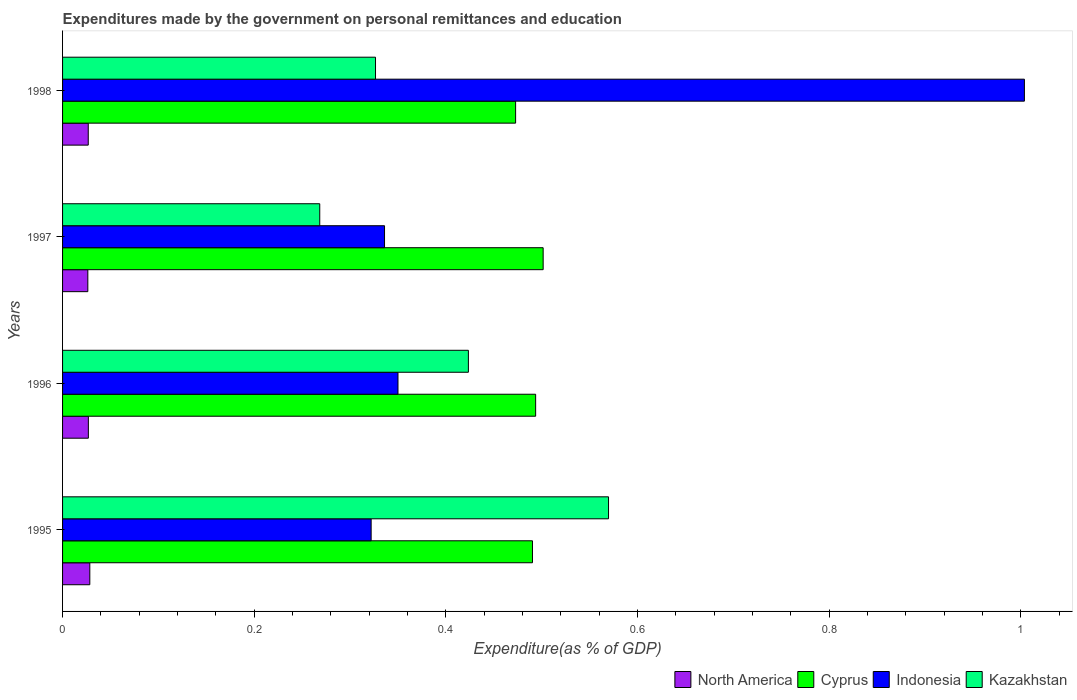How many different coloured bars are there?
Provide a succinct answer. 4. Are the number of bars per tick equal to the number of legend labels?
Your answer should be compact. Yes. Are the number of bars on each tick of the Y-axis equal?
Your response must be concise. Yes. What is the label of the 1st group of bars from the top?
Your response must be concise. 1998. What is the expenditures made by the government on personal remittances and education in Kazakhstan in 1998?
Ensure brevity in your answer.  0.33. Across all years, what is the maximum expenditures made by the government on personal remittances and education in Kazakhstan?
Your answer should be very brief. 0.57. Across all years, what is the minimum expenditures made by the government on personal remittances and education in Indonesia?
Your response must be concise. 0.32. What is the total expenditures made by the government on personal remittances and education in Cyprus in the graph?
Keep it short and to the point. 1.96. What is the difference between the expenditures made by the government on personal remittances and education in Cyprus in 1995 and that in 1996?
Offer a very short reply. -0. What is the difference between the expenditures made by the government on personal remittances and education in Kazakhstan in 1997 and the expenditures made by the government on personal remittances and education in Indonesia in 1998?
Your answer should be compact. -0.74. What is the average expenditures made by the government on personal remittances and education in Kazakhstan per year?
Ensure brevity in your answer.  0.4. In the year 1997, what is the difference between the expenditures made by the government on personal remittances and education in Indonesia and expenditures made by the government on personal remittances and education in Kazakhstan?
Offer a very short reply. 0.07. What is the ratio of the expenditures made by the government on personal remittances and education in Indonesia in 1996 to that in 1998?
Your answer should be compact. 0.35. Is the expenditures made by the government on personal remittances and education in Kazakhstan in 1995 less than that in 1996?
Your answer should be very brief. No. Is the difference between the expenditures made by the government on personal remittances and education in Indonesia in 1995 and 1997 greater than the difference between the expenditures made by the government on personal remittances and education in Kazakhstan in 1995 and 1997?
Offer a very short reply. No. What is the difference between the highest and the second highest expenditures made by the government on personal remittances and education in Kazakhstan?
Your response must be concise. 0.15. What is the difference between the highest and the lowest expenditures made by the government on personal remittances and education in North America?
Provide a short and direct response. 0. In how many years, is the expenditures made by the government on personal remittances and education in Cyprus greater than the average expenditures made by the government on personal remittances and education in Cyprus taken over all years?
Ensure brevity in your answer.  3. Is it the case that in every year, the sum of the expenditures made by the government on personal remittances and education in Kazakhstan and expenditures made by the government on personal remittances and education in North America is greater than the sum of expenditures made by the government on personal remittances and education in Indonesia and expenditures made by the government on personal remittances and education in Cyprus?
Ensure brevity in your answer.  No. What does the 2nd bar from the bottom in 1997 represents?
Your response must be concise. Cyprus. Is it the case that in every year, the sum of the expenditures made by the government on personal remittances and education in Indonesia and expenditures made by the government on personal remittances and education in Cyprus is greater than the expenditures made by the government on personal remittances and education in Kazakhstan?
Your response must be concise. Yes. How many years are there in the graph?
Give a very brief answer. 4. Are the values on the major ticks of X-axis written in scientific E-notation?
Keep it short and to the point. No. Does the graph contain grids?
Make the answer very short. No. Where does the legend appear in the graph?
Your answer should be very brief. Bottom right. What is the title of the graph?
Provide a succinct answer. Expenditures made by the government on personal remittances and education. What is the label or title of the X-axis?
Make the answer very short. Expenditure(as % of GDP). What is the label or title of the Y-axis?
Give a very brief answer. Years. What is the Expenditure(as % of GDP) of North America in 1995?
Ensure brevity in your answer.  0.03. What is the Expenditure(as % of GDP) in Cyprus in 1995?
Keep it short and to the point. 0.49. What is the Expenditure(as % of GDP) in Indonesia in 1995?
Your answer should be very brief. 0.32. What is the Expenditure(as % of GDP) of Kazakhstan in 1995?
Keep it short and to the point. 0.57. What is the Expenditure(as % of GDP) of North America in 1996?
Provide a short and direct response. 0.03. What is the Expenditure(as % of GDP) of Cyprus in 1996?
Provide a short and direct response. 0.49. What is the Expenditure(as % of GDP) of Indonesia in 1996?
Your answer should be very brief. 0.35. What is the Expenditure(as % of GDP) in Kazakhstan in 1996?
Offer a very short reply. 0.42. What is the Expenditure(as % of GDP) of North America in 1997?
Offer a terse response. 0.03. What is the Expenditure(as % of GDP) in Cyprus in 1997?
Offer a terse response. 0.5. What is the Expenditure(as % of GDP) of Indonesia in 1997?
Provide a short and direct response. 0.34. What is the Expenditure(as % of GDP) in Kazakhstan in 1997?
Make the answer very short. 0.27. What is the Expenditure(as % of GDP) in North America in 1998?
Keep it short and to the point. 0.03. What is the Expenditure(as % of GDP) in Cyprus in 1998?
Your answer should be very brief. 0.47. What is the Expenditure(as % of GDP) in Indonesia in 1998?
Offer a very short reply. 1. What is the Expenditure(as % of GDP) of Kazakhstan in 1998?
Your answer should be very brief. 0.33. Across all years, what is the maximum Expenditure(as % of GDP) in North America?
Offer a very short reply. 0.03. Across all years, what is the maximum Expenditure(as % of GDP) in Cyprus?
Offer a very short reply. 0.5. Across all years, what is the maximum Expenditure(as % of GDP) in Indonesia?
Your response must be concise. 1. Across all years, what is the maximum Expenditure(as % of GDP) in Kazakhstan?
Provide a succinct answer. 0.57. Across all years, what is the minimum Expenditure(as % of GDP) in North America?
Your answer should be compact. 0.03. Across all years, what is the minimum Expenditure(as % of GDP) in Cyprus?
Ensure brevity in your answer.  0.47. Across all years, what is the minimum Expenditure(as % of GDP) in Indonesia?
Offer a very short reply. 0.32. Across all years, what is the minimum Expenditure(as % of GDP) in Kazakhstan?
Your response must be concise. 0.27. What is the total Expenditure(as % of GDP) of North America in the graph?
Your answer should be compact. 0.11. What is the total Expenditure(as % of GDP) in Cyprus in the graph?
Offer a terse response. 1.96. What is the total Expenditure(as % of GDP) of Indonesia in the graph?
Give a very brief answer. 2.01. What is the total Expenditure(as % of GDP) in Kazakhstan in the graph?
Your answer should be very brief. 1.59. What is the difference between the Expenditure(as % of GDP) of North America in 1995 and that in 1996?
Offer a terse response. 0. What is the difference between the Expenditure(as % of GDP) in Cyprus in 1995 and that in 1996?
Your response must be concise. -0. What is the difference between the Expenditure(as % of GDP) of Indonesia in 1995 and that in 1996?
Provide a succinct answer. -0.03. What is the difference between the Expenditure(as % of GDP) in Kazakhstan in 1995 and that in 1996?
Offer a very short reply. 0.15. What is the difference between the Expenditure(as % of GDP) of North America in 1995 and that in 1997?
Offer a very short reply. 0. What is the difference between the Expenditure(as % of GDP) in Cyprus in 1995 and that in 1997?
Keep it short and to the point. -0.01. What is the difference between the Expenditure(as % of GDP) of Indonesia in 1995 and that in 1997?
Ensure brevity in your answer.  -0.01. What is the difference between the Expenditure(as % of GDP) of Kazakhstan in 1995 and that in 1997?
Your answer should be very brief. 0.3. What is the difference between the Expenditure(as % of GDP) of North America in 1995 and that in 1998?
Your answer should be very brief. 0. What is the difference between the Expenditure(as % of GDP) of Cyprus in 1995 and that in 1998?
Provide a succinct answer. 0.02. What is the difference between the Expenditure(as % of GDP) in Indonesia in 1995 and that in 1998?
Keep it short and to the point. -0.68. What is the difference between the Expenditure(as % of GDP) in Kazakhstan in 1995 and that in 1998?
Offer a very short reply. 0.24. What is the difference between the Expenditure(as % of GDP) in North America in 1996 and that in 1997?
Keep it short and to the point. 0. What is the difference between the Expenditure(as % of GDP) in Cyprus in 1996 and that in 1997?
Your answer should be compact. -0.01. What is the difference between the Expenditure(as % of GDP) of Indonesia in 1996 and that in 1997?
Offer a very short reply. 0.01. What is the difference between the Expenditure(as % of GDP) in Kazakhstan in 1996 and that in 1997?
Offer a very short reply. 0.16. What is the difference between the Expenditure(as % of GDP) of Cyprus in 1996 and that in 1998?
Your answer should be compact. 0.02. What is the difference between the Expenditure(as % of GDP) of Indonesia in 1996 and that in 1998?
Provide a short and direct response. -0.65. What is the difference between the Expenditure(as % of GDP) in Kazakhstan in 1996 and that in 1998?
Keep it short and to the point. 0.1. What is the difference between the Expenditure(as % of GDP) of North America in 1997 and that in 1998?
Offer a very short reply. -0. What is the difference between the Expenditure(as % of GDP) of Cyprus in 1997 and that in 1998?
Provide a short and direct response. 0.03. What is the difference between the Expenditure(as % of GDP) of Indonesia in 1997 and that in 1998?
Your answer should be very brief. -0.67. What is the difference between the Expenditure(as % of GDP) of Kazakhstan in 1997 and that in 1998?
Give a very brief answer. -0.06. What is the difference between the Expenditure(as % of GDP) of North America in 1995 and the Expenditure(as % of GDP) of Cyprus in 1996?
Keep it short and to the point. -0.47. What is the difference between the Expenditure(as % of GDP) of North America in 1995 and the Expenditure(as % of GDP) of Indonesia in 1996?
Your response must be concise. -0.32. What is the difference between the Expenditure(as % of GDP) in North America in 1995 and the Expenditure(as % of GDP) in Kazakhstan in 1996?
Provide a short and direct response. -0.4. What is the difference between the Expenditure(as % of GDP) in Cyprus in 1995 and the Expenditure(as % of GDP) in Indonesia in 1996?
Offer a very short reply. 0.14. What is the difference between the Expenditure(as % of GDP) of Cyprus in 1995 and the Expenditure(as % of GDP) of Kazakhstan in 1996?
Make the answer very short. 0.07. What is the difference between the Expenditure(as % of GDP) in Indonesia in 1995 and the Expenditure(as % of GDP) in Kazakhstan in 1996?
Keep it short and to the point. -0.1. What is the difference between the Expenditure(as % of GDP) in North America in 1995 and the Expenditure(as % of GDP) in Cyprus in 1997?
Make the answer very short. -0.47. What is the difference between the Expenditure(as % of GDP) in North America in 1995 and the Expenditure(as % of GDP) in Indonesia in 1997?
Your answer should be very brief. -0.31. What is the difference between the Expenditure(as % of GDP) in North America in 1995 and the Expenditure(as % of GDP) in Kazakhstan in 1997?
Give a very brief answer. -0.24. What is the difference between the Expenditure(as % of GDP) in Cyprus in 1995 and the Expenditure(as % of GDP) in Indonesia in 1997?
Your answer should be very brief. 0.15. What is the difference between the Expenditure(as % of GDP) in Cyprus in 1995 and the Expenditure(as % of GDP) in Kazakhstan in 1997?
Make the answer very short. 0.22. What is the difference between the Expenditure(as % of GDP) in Indonesia in 1995 and the Expenditure(as % of GDP) in Kazakhstan in 1997?
Give a very brief answer. 0.05. What is the difference between the Expenditure(as % of GDP) in North America in 1995 and the Expenditure(as % of GDP) in Cyprus in 1998?
Offer a terse response. -0.44. What is the difference between the Expenditure(as % of GDP) in North America in 1995 and the Expenditure(as % of GDP) in Indonesia in 1998?
Give a very brief answer. -0.98. What is the difference between the Expenditure(as % of GDP) of North America in 1995 and the Expenditure(as % of GDP) of Kazakhstan in 1998?
Give a very brief answer. -0.3. What is the difference between the Expenditure(as % of GDP) of Cyprus in 1995 and the Expenditure(as % of GDP) of Indonesia in 1998?
Give a very brief answer. -0.51. What is the difference between the Expenditure(as % of GDP) of Cyprus in 1995 and the Expenditure(as % of GDP) of Kazakhstan in 1998?
Provide a succinct answer. 0.16. What is the difference between the Expenditure(as % of GDP) of Indonesia in 1995 and the Expenditure(as % of GDP) of Kazakhstan in 1998?
Give a very brief answer. -0. What is the difference between the Expenditure(as % of GDP) of North America in 1996 and the Expenditure(as % of GDP) of Cyprus in 1997?
Your answer should be compact. -0.47. What is the difference between the Expenditure(as % of GDP) of North America in 1996 and the Expenditure(as % of GDP) of Indonesia in 1997?
Make the answer very short. -0.31. What is the difference between the Expenditure(as % of GDP) of North America in 1996 and the Expenditure(as % of GDP) of Kazakhstan in 1997?
Your response must be concise. -0.24. What is the difference between the Expenditure(as % of GDP) in Cyprus in 1996 and the Expenditure(as % of GDP) in Indonesia in 1997?
Your answer should be compact. 0.16. What is the difference between the Expenditure(as % of GDP) in Cyprus in 1996 and the Expenditure(as % of GDP) in Kazakhstan in 1997?
Your answer should be very brief. 0.23. What is the difference between the Expenditure(as % of GDP) in Indonesia in 1996 and the Expenditure(as % of GDP) in Kazakhstan in 1997?
Give a very brief answer. 0.08. What is the difference between the Expenditure(as % of GDP) of North America in 1996 and the Expenditure(as % of GDP) of Cyprus in 1998?
Offer a very short reply. -0.45. What is the difference between the Expenditure(as % of GDP) in North America in 1996 and the Expenditure(as % of GDP) in Indonesia in 1998?
Your answer should be very brief. -0.98. What is the difference between the Expenditure(as % of GDP) of North America in 1996 and the Expenditure(as % of GDP) of Kazakhstan in 1998?
Ensure brevity in your answer.  -0.3. What is the difference between the Expenditure(as % of GDP) in Cyprus in 1996 and the Expenditure(as % of GDP) in Indonesia in 1998?
Your response must be concise. -0.51. What is the difference between the Expenditure(as % of GDP) of Cyprus in 1996 and the Expenditure(as % of GDP) of Kazakhstan in 1998?
Make the answer very short. 0.17. What is the difference between the Expenditure(as % of GDP) in Indonesia in 1996 and the Expenditure(as % of GDP) in Kazakhstan in 1998?
Your answer should be very brief. 0.02. What is the difference between the Expenditure(as % of GDP) of North America in 1997 and the Expenditure(as % of GDP) of Cyprus in 1998?
Your response must be concise. -0.45. What is the difference between the Expenditure(as % of GDP) in North America in 1997 and the Expenditure(as % of GDP) in Indonesia in 1998?
Offer a terse response. -0.98. What is the difference between the Expenditure(as % of GDP) of North America in 1997 and the Expenditure(as % of GDP) of Kazakhstan in 1998?
Ensure brevity in your answer.  -0.3. What is the difference between the Expenditure(as % of GDP) of Cyprus in 1997 and the Expenditure(as % of GDP) of Indonesia in 1998?
Make the answer very short. -0.5. What is the difference between the Expenditure(as % of GDP) of Cyprus in 1997 and the Expenditure(as % of GDP) of Kazakhstan in 1998?
Give a very brief answer. 0.17. What is the difference between the Expenditure(as % of GDP) of Indonesia in 1997 and the Expenditure(as % of GDP) of Kazakhstan in 1998?
Provide a succinct answer. 0.01. What is the average Expenditure(as % of GDP) in North America per year?
Ensure brevity in your answer.  0.03. What is the average Expenditure(as % of GDP) in Cyprus per year?
Provide a short and direct response. 0.49. What is the average Expenditure(as % of GDP) in Indonesia per year?
Make the answer very short. 0.5. What is the average Expenditure(as % of GDP) in Kazakhstan per year?
Provide a short and direct response. 0.4. In the year 1995, what is the difference between the Expenditure(as % of GDP) of North America and Expenditure(as % of GDP) of Cyprus?
Provide a short and direct response. -0.46. In the year 1995, what is the difference between the Expenditure(as % of GDP) in North America and Expenditure(as % of GDP) in Indonesia?
Make the answer very short. -0.29. In the year 1995, what is the difference between the Expenditure(as % of GDP) in North America and Expenditure(as % of GDP) in Kazakhstan?
Your answer should be compact. -0.54. In the year 1995, what is the difference between the Expenditure(as % of GDP) in Cyprus and Expenditure(as % of GDP) in Indonesia?
Your response must be concise. 0.17. In the year 1995, what is the difference between the Expenditure(as % of GDP) in Cyprus and Expenditure(as % of GDP) in Kazakhstan?
Provide a succinct answer. -0.08. In the year 1995, what is the difference between the Expenditure(as % of GDP) of Indonesia and Expenditure(as % of GDP) of Kazakhstan?
Give a very brief answer. -0.25. In the year 1996, what is the difference between the Expenditure(as % of GDP) in North America and Expenditure(as % of GDP) in Cyprus?
Ensure brevity in your answer.  -0.47. In the year 1996, what is the difference between the Expenditure(as % of GDP) in North America and Expenditure(as % of GDP) in Indonesia?
Your answer should be very brief. -0.32. In the year 1996, what is the difference between the Expenditure(as % of GDP) in North America and Expenditure(as % of GDP) in Kazakhstan?
Your answer should be compact. -0.4. In the year 1996, what is the difference between the Expenditure(as % of GDP) of Cyprus and Expenditure(as % of GDP) of Indonesia?
Your answer should be compact. 0.14. In the year 1996, what is the difference between the Expenditure(as % of GDP) of Cyprus and Expenditure(as % of GDP) of Kazakhstan?
Provide a short and direct response. 0.07. In the year 1996, what is the difference between the Expenditure(as % of GDP) of Indonesia and Expenditure(as % of GDP) of Kazakhstan?
Your answer should be compact. -0.07. In the year 1997, what is the difference between the Expenditure(as % of GDP) in North America and Expenditure(as % of GDP) in Cyprus?
Provide a succinct answer. -0.48. In the year 1997, what is the difference between the Expenditure(as % of GDP) of North America and Expenditure(as % of GDP) of Indonesia?
Provide a short and direct response. -0.31. In the year 1997, what is the difference between the Expenditure(as % of GDP) of North America and Expenditure(as % of GDP) of Kazakhstan?
Give a very brief answer. -0.24. In the year 1997, what is the difference between the Expenditure(as % of GDP) of Cyprus and Expenditure(as % of GDP) of Indonesia?
Offer a very short reply. 0.17. In the year 1997, what is the difference between the Expenditure(as % of GDP) in Cyprus and Expenditure(as % of GDP) in Kazakhstan?
Your response must be concise. 0.23. In the year 1997, what is the difference between the Expenditure(as % of GDP) in Indonesia and Expenditure(as % of GDP) in Kazakhstan?
Your answer should be very brief. 0.07. In the year 1998, what is the difference between the Expenditure(as % of GDP) in North America and Expenditure(as % of GDP) in Cyprus?
Provide a succinct answer. -0.45. In the year 1998, what is the difference between the Expenditure(as % of GDP) in North America and Expenditure(as % of GDP) in Indonesia?
Give a very brief answer. -0.98. In the year 1998, what is the difference between the Expenditure(as % of GDP) in North America and Expenditure(as % of GDP) in Kazakhstan?
Offer a terse response. -0.3. In the year 1998, what is the difference between the Expenditure(as % of GDP) in Cyprus and Expenditure(as % of GDP) in Indonesia?
Your response must be concise. -0.53. In the year 1998, what is the difference between the Expenditure(as % of GDP) in Cyprus and Expenditure(as % of GDP) in Kazakhstan?
Your answer should be compact. 0.15. In the year 1998, what is the difference between the Expenditure(as % of GDP) of Indonesia and Expenditure(as % of GDP) of Kazakhstan?
Your response must be concise. 0.68. What is the ratio of the Expenditure(as % of GDP) in North America in 1995 to that in 1996?
Keep it short and to the point. 1.06. What is the ratio of the Expenditure(as % of GDP) of Kazakhstan in 1995 to that in 1996?
Offer a terse response. 1.35. What is the ratio of the Expenditure(as % of GDP) in North America in 1995 to that in 1997?
Make the answer very short. 1.08. What is the ratio of the Expenditure(as % of GDP) in Cyprus in 1995 to that in 1997?
Keep it short and to the point. 0.98. What is the ratio of the Expenditure(as % of GDP) in Indonesia in 1995 to that in 1997?
Offer a very short reply. 0.96. What is the ratio of the Expenditure(as % of GDP) of Kazakhstan in 1995 to that in 1997?
Your response must be concise. 2.12. What is the ratio of the Expenditure(as % of GDP) in North America in 1995 to that in 1998?
Provide a short and direct response. 1.06. What is the ratio of the Expenditure(as % of GDP) of Cyprus in 1995 to that in 1998?
Your answer should be compact. 1.04. What is the ratio of the Expenditure(as % of GDP) of Indonesia in 1995 to that in 1998?
Your answer should be compact. 0.32. What is the ratio of the Expenditure(as % of GDP) of Kazakhstan in 1995 to that in 1998?
Your response must be concise. 1.74. What is the ratio of the Expenditure(as % of GDP) of North America in 1996 to that in 1997?
Give a very brief answer. 1.02. What is the ratio of the Expenditure(as % of GDP) in Cyprus in 1996 to that in 1997?
Provide a succinct answer. 0.98. What is the ratio of the Expenditure(as % of GDP) in Indonesia in 1996 to that in 1997?
Offer a very short reply. 1.04. What is the ratio of the Expenditure(as % of GDP) in Kazakhstan in 1996 to that in 1997?
Keep it short and to the point. 1.58. What is the ratio of the Expenditure(as % of GDP) in North America in 1996 to that in 1998?
Your response must be concise. 1. What is the ratio of the Expenditure(as % of GDP) of Cyprus in 1996 to that in 1998?
Provide a short and direct response. 1.04. What is the ratio of the Expenditure(as % of GDP) of Indonesia in 1996 to that in 1998?
Make the answer very short. 0.35. What is the ratio of the Expenditure(as % of GDP) in Kazakhstan in 1996 to that in 1998?
Offer a terse response. 1.3. What is the ratio of the Expenditure(as % of GDP) in North America in 1997 to that in 1998?
Ensure brevity in your answer.  0.98. What is the ratio of the Expenditure(as % of GDP) of Cyprus in 1997 to that in 1998?
Offer a very short reply. 1.06. What is the ratio of the Expenditure(as % of GDP) in Indonesia in 1997 to that in 1998?
Your answer should be compact. 0.33. What is the ratio of the Expenditure(as % of GDP) of Kazakhstan in 1997 to that in 1998?
Offer a very short reply. 0.82. What is the difference between the highest and the second highest Expenditure(as % of GDP) in North America?
Offer a very short reply. 0. What is the difference between the highest and the second highest Expenditure(as % of GDP) in Cyprus?
Offer a terse response. 0.01. What is the difference between the highest and the second highest Expenditure(as % of GDP) of Indonesia?
Keep it short and to the point. 0.65. What is the difference between the highest and the second highest Expenditure(as % of GDP) in Kazakhstan?
Your response must be concise. 0.15. What is the difference between the highest and the lowest Expenditure(as % of GDP) in North America?
Offer a terse response. 0. What is the difference between the highest and the lowest Expenditure(as % of GDP) of Cyprus?
Provide a succinct answer. 0.03. What is the difference between the highest and the lowest Expenditure(as % of GDP) in Indonesia?
Offer a very short reply. 0.68. What is the difference between the highest and the lowest Expenditure(as % of GDP) in Kazakhstan?
Ensure brevity in your answer.  0.3. 